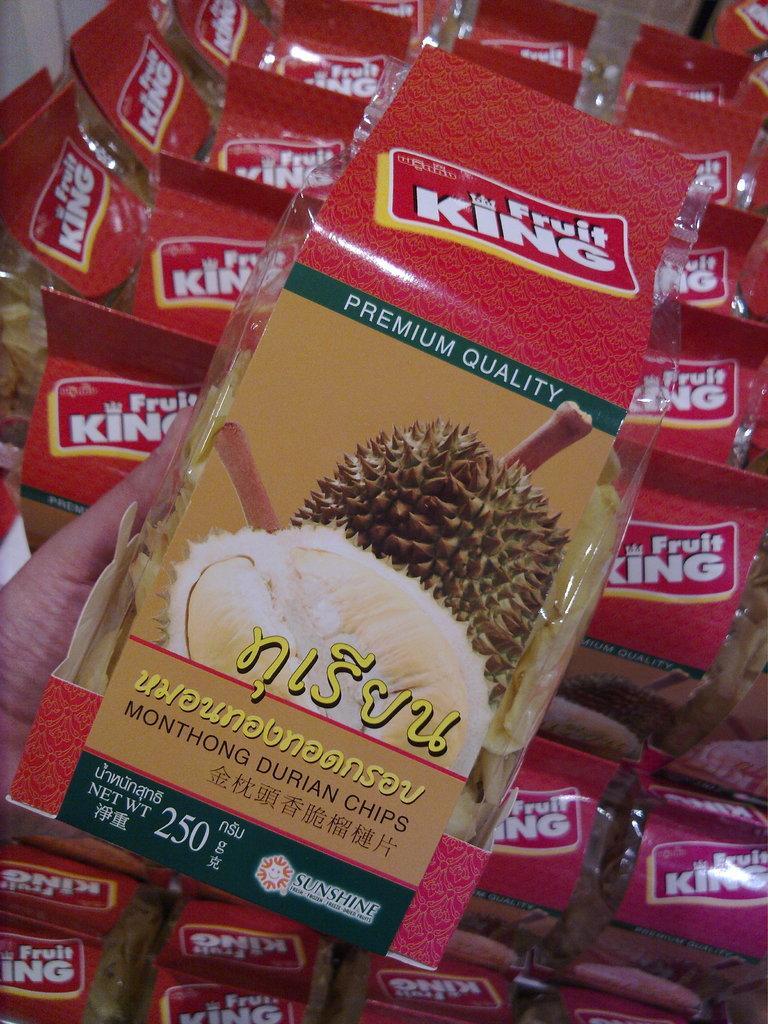How would you summarize this image in a sentence or two? In the image there is a packet of packed fruits being held in a person's hand and behind that packet there are many other packets. 